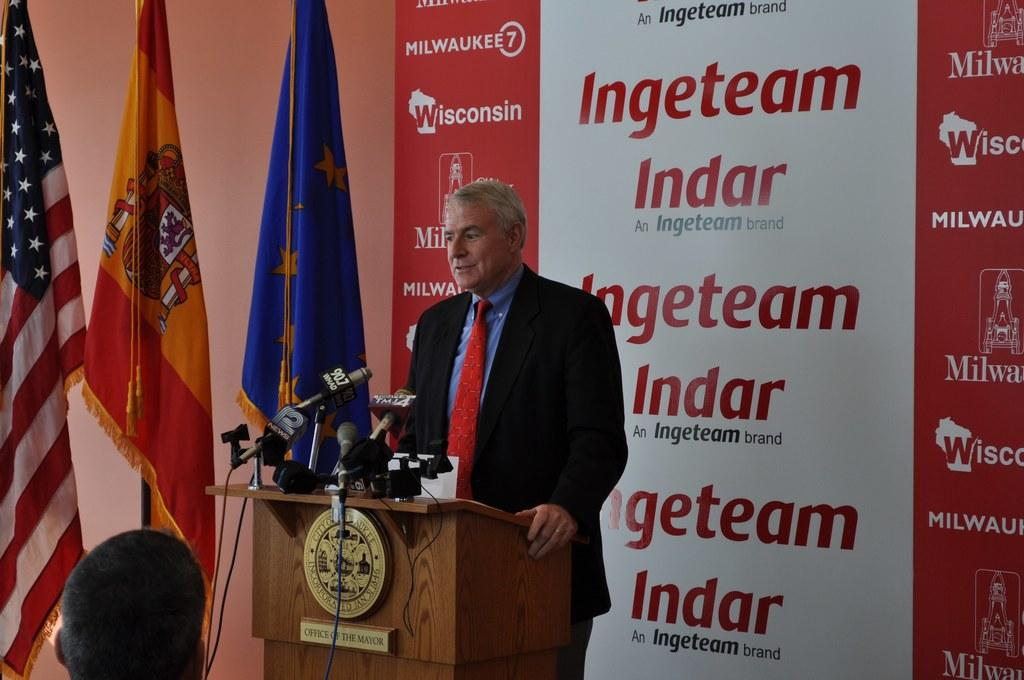What is located on the left side of the image? There are flags, a podium, microphones, cables, and a person's head visible on the left side of the image. What is the person's head likely to be attached to? The person's head is likely attached to their body, which is not fully visible in the image. What is in the middle of the image? There is a person standing in the middle of the image. What is on the right side of the image? There is a banner on the right side of the image. Can you hear the goldfish swimming in the image? There are no goldfish present in the image, so it is not possible to hear them swimming. What type of metal is the copper used for in the image? There is no copper present in the image. 